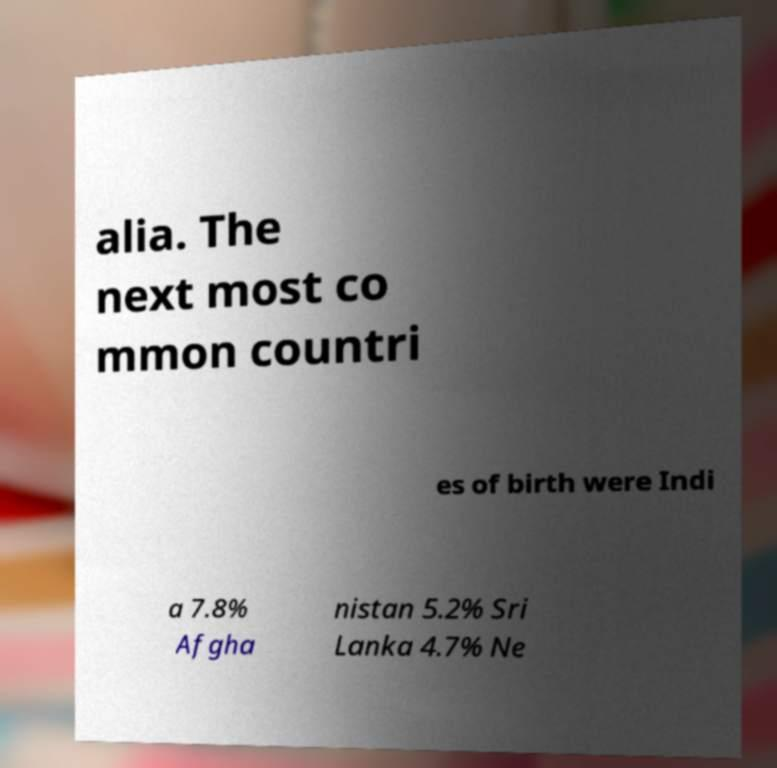Could you extract and type out the text from this image? alia. The next most co mmon countri es of birth were Indi a 7.8% Afgha nistan 5.2% Sri Lanka 4.7% Ne 